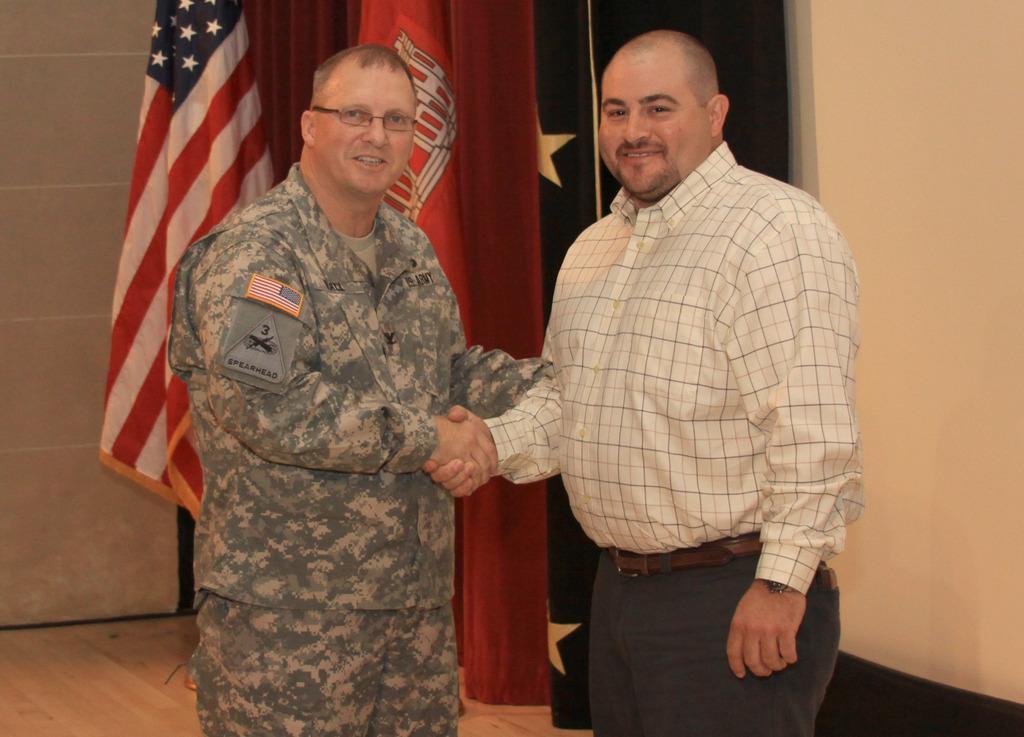Describe this image in one or two sentences. In this image we can see two men standing on the floor. On the backside we can see the flags, a curtain and a wall. 